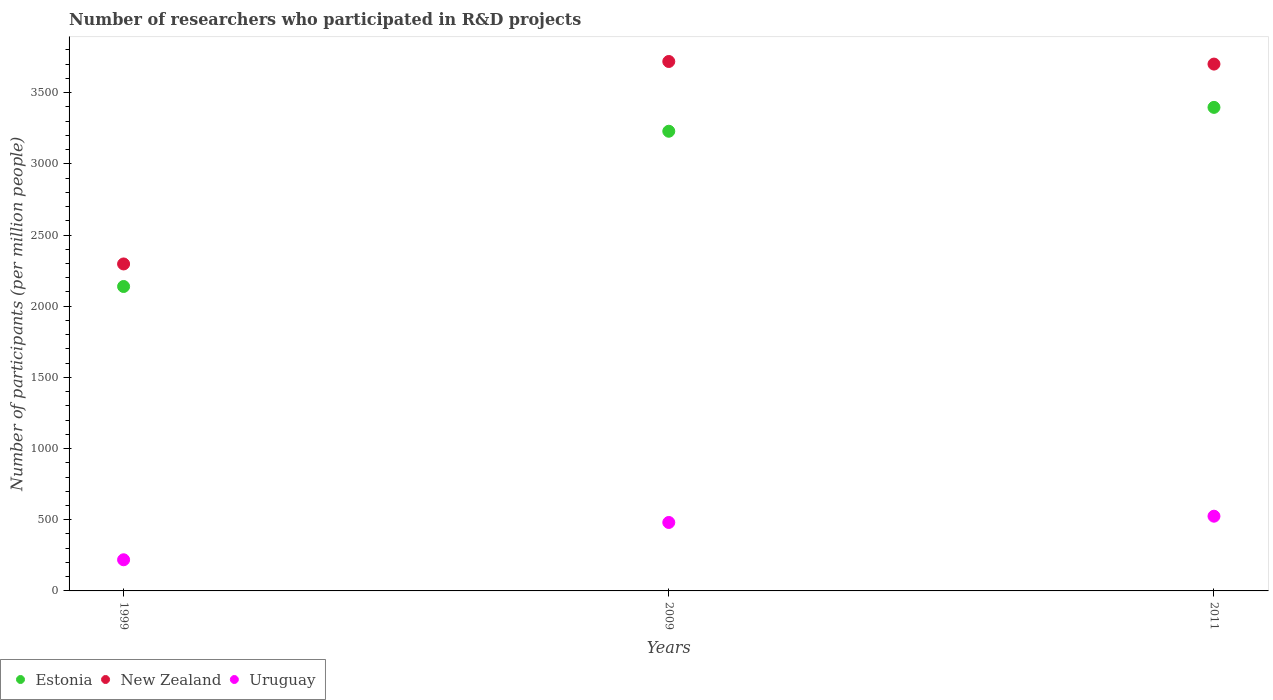Is the number of dotlines equal to the number of legend labels?
Offer a very short reply. Yes. What is the number of researchers who participated in R&D projects in New Zealand in 2011?
Your answer should be very brief. 3700.77. Across all years, what is the maximum number of researchers who participated in R&D projects in Estonia?
Provide a succinct answer. 3396.66. Across all years, what is the minimum number of researchers who participated in R&D projects in New Zealand?
Your answer should be compact. 2296.8. In which year was the number of researchers who participated in R&D projects in Uruguay minimum?
Make the answer very short. 1999. What is the total number of researchers who participated in R&D projects in New Zealand in the graph?
Make the answer very short. 9716.57. What is the difference between the number of researchers who participated in R&D projects in Estonia in 2009 and that in 2011?
Provide a short and direct response. -167.65. What is the difference between the number of researchers who participated in R&D projects in New Zealand in 2011 and the number of researchers who participated in R&D projects in Estonia in 2009?
Your answer should be very brief. 471.76. What is the average number of researchers who participated in R&D projects in New Zealand per year?
Provide a succinct answer. 3238.86. In the year 1999, what is the difference between the number of researchers who participated in R&D projects in Uruguay and number of researchers who participated in R&D projects in New Zealand?
Offer a very short reply. -2077.98. In how many years, is the number of researchers who participated in R&D projects in Uruguay greater than 1900?
Your response must be concise. 0. What is the ratio of the number of researchers who participated in R&D projects in Uruguay in 2009 to that in 2011?
Keep it short and to the point. 0.92. Is the number of researchers who participated in R&D projects in Estonia in 1999 less than that in 2011?
Offer a very short reply. Yes. Is the difference between the number of researchers who participated in R&D projects in Uruguay in 2009 and 2011 greater than the difference between the number of researchers who participated in R&D projects in New Zealand in 2009 and 2011?
Provide a short and direct response. No. What is the difference between the highest and the second highest number of researchers who participated in R&D projects in Estonia?
Provide a succinct answer. 167.65. What is the difference between the highest and the lowest number of researchers who participated in R&D projects in Estonia?
Make the answer very short. 1258.21. In how many years, is the number of researchers who participated in R&D projects in Uruguay greater than the average number of researchers who participated in R&D projects in Uruguay taken over all years?
Offer a very short reply. 2. Is the sum of the number of researchers who participated in R&D projects in New Zealand in 2009 and 2011 greater than the maximum number of researchers who participated in R&D projects in Uruguay across all years?
Give a very brief answer. Yes. Does the number of researchers who participated in R&D projects in Uruguay monotonically increase over the years?
Keep it short and to the point. Yes. Is the number of researchers who participated in R&D projects in Estonia strictly less than the number of researchers who participated in R&D projects in Uruguay over the years?
Give a very brief answer. No. How many dotlines are there?
Your answer should be compact. 3. What is the difference between two consecutive major ticks on the Y-axis?
Provide a succinct answer. 500. Are the values on the major ticks of Y-axis written in scientific E-notation?
Your response must be concise. No. What is the title of the graph?
Your answer should be very brief. Number of researchers who participated in R&D projects. What is the label or title of the Y-axis?
Give a very brief answer. Number of participants (per million people). What is the Number of participants (per million people) in Estonia in 1999?
Give a very brief answer. 2138.45. What is the Number of participants (per million people) of New Zealand in 1999?
Your response must be concise. 2296.8. What is the Number of participants (per million people) in Uruguay in 1999?
Give a very brief answer. 218.82. What is the Number of participants (per million people) in Estonia in 2009?
Make the answer very short. 3229.01. What is the Number of participants (per million people) of New Zealand in 2009?
Provide a succinct answer. 3719. What is the Number of participants (per million people) in Uruguay in 2009?
Provide a short and direct response. 480.85. What is the Number of participants (per million people) of Estonia in 2011?
Provide a succinct answer. 3396.66. What is the Number of participants (per million people) of New Zealand in 2011?
Give a very brief answer. 3700.77. What is the Number of participants (per million people) in Uruguay in 2011?
Give a very brief answer. 524.87. Across all years, what is the maximum Number of participants (per million people) in Estonia?
Make the answer very short. 3396.66. Across all years, what is the maximum Number of participants (per million people) in New Zealand?
Provide a short and direct response. 3719. Across all years, what is the maximum Number of participants (per million people) in Uruguay?
Offer a very short reply. 524.87. Across all years, what is the minimum Number of participants (per million people) in Estonia?
Your answer should be compact. 2138.45. Across all years, what is the minimum Number of participants (per million people) of New Zealand?
Your answer should be very brief. 2296.8. Across all years, what is the minimum Number of participants (per million people) of Uruguay?
Provide a short and direct response. 218.82. What is the total Number of participants (per million people) of Estonia in the graph?
Give a very brief answer. 8764.12. What is the total Number of participants (per million people) of New Zealand in the graph?
Your response must be concise. 9716.57. What is the total Number of participants (per million people) in Uruguay in the graph?
Provide a short and direct response. 1224.54. What is the difference between the Number of participants (per million people) in Estonia in 1999 and that in 2009?
Ensure brevity in your answer.  -1090.56. What is the difference between the Number of participants (per million people) of New Zealand in 1999 and that in 2009?
Ensure brevity in your answer.  -1422.2. What is the difference between the Number of participants (per million people) in Uruguay in 1999 and that in 2009?
Your response must be concise. -262.04. What is the difference between the Number of participants (per million people) in Estonia in 1999 and that in 2011?
Provide a succinct answer. -1258.21. What is the difference between the Number of participants (per million people) of New Zealand in 1999 and that in 2011?
Offer a very short reply. -1403.98. What is the difference between the Number of participants (per million people) of Uruguay in 1999 and that in 2011?
Make the answer very short. -306.05. What is the difference between the Number of participants (per million people) of Estonia in 2009 and that in 2011?
Make the answer very short. -167.65. What is the difference between the Number of participants (per million people) in New Zealand in 2009 and that in 2011?
Provide a short and direct response. 18.22. What is the difference between the Number of participants (per million people) of Uruguay in 2009 and that in 2011?
Provide a succinct answer. -44.01. What is the difference between the Number of participants (per million people) in Estonia in 1999 and the Number of participants (per million people) in New Zealand in 2009?
Your response must be concise. -1580.55. What is the difference between the Number of participants (per million people) in Estonia in 1999 and the Number of participants (per million people) in Uruguay in 2009?
Your answer should be compact. 1657.59. What is the difference between the Number of participants (per million people) in New Zealand in 1999 and the Number of participants (per million people) in Uruguay in 2009?
Provide a succinct answer. 1815.94. What is the difference between the Number of participants (per million people) in Estonia in 1999 and the Number of participants (per million people) in New Zealand in 2011?
Provide a succinct answer. -1562.33. What is the difference between the Number of participants (per million people) of Estonia in 1999 and the Number of participants (per million people) of Uruguay in 2011?
Give a very brief answer. 1613.58. What is the difference between the Number of participants (per million people) of New Zealand in 1999 and the Number of participants (per million people) of Uruguay in 2011?
Your answer should be compact. 1771.93. What is the difference between the Number of participants (per million people) of Estonia in 2009 and the Number of participants (per million people) of New Zealand in 2011?
Offer a terse response. -471.76. What is the difference between the Number of participants (per million people) in Estonia in 2009 and the Number of participants (per million people) in Uruguay in 2011?
Your answer should be compact. 2704.14. What is the difference between the Number of participants (per million people) of New Zealand in 2009 and the Number of participants (per million people) of Uruguay in 2011?
Give a very brief answer. 3194.13. What is the average Number of participants (per million people) of Estonia per year?
Provide a short and direct response. 2921.37. What is the average Number of participants (per million people) in New Zealand per year?
Provide a short and direct response. 3238.86. What is the average Number of participants (per million people) in Uruguay per year?
Make the answer very short. 408.18. In the year 1999, what is the difference between the Number of participants (per million people) in Estonia and Number of participants (per million people) in New Zealand?
Ensure brevity in your answer.  -158.35. In the year 1999, what is the difference between the Number of participants (per million people) of Estonia and Number of participants (per million people) of Uruguay?
Make the answer very short. 1919.63. In the year 1999, what is the difference between the Number of participants (per million people) of New Zealand and Number of participants (per million people) of Uruguay?
Give a very brief answer. 2077.98. In the year 2009, what is the difference between the Number of participants (per million people) in Estonia and Number of participants (per million people) in New Zealand?
Offer a terse response. -489.99. In the year 2009, what is the difference between the Number of participants (per million people) in Estonia and Number of participants (per million people) in Uruguay?
Offer a very short reply. 2748.16. In the year 2009, what is the difference between the Number of participants (per million people) in New Zealand and Number of participants (per million people) in Uruguay?
Give a very brief answer. 3238.14. In the year 2011, what is the difference between the Number of participants (per million people) of Estonia and Number of participants (per million people) of New Zealand?
Provide a short and direct response. -304.11. In the year 2011, what is the difference between the Number of participants (per million people) of Estonia and Number of participants (per million people) of Uruguay?
Provide a short and direct response. 2871.79. In the year 2011, what is the difference between the Number of participants (per million people) in New Zealand and Number of participants (per million people) in Uruguay?
Your response must be concise. 3175.91. What is the ratio of the Number of participants (per million people) of Estonia in 1999 to that in 2009?
Your answer should be very brief. 0.66. What is the ratio of the Number of participants (per million people) of New Zealand in 1999 to that in 2009?
Offer a terse response. 0.62. What is the ratio of the Number of participants (per million people) of Uruguay in 1999 to that in 2009?
Ensure brevity in your answer.  0.46. What is the ratio of the Number of participants (per million people) of Estonia in 1999 to that in 2011?
Ensure brevity in your answer.  0.63. What is the ratio of the Number of participants (per million people) of New Zealand in 1999 to that in 2011?
Keep it short and to the point. 0.62. What is the ratio of the Number of participants (per million people) of Uruguay in 1999 to that in 2011?
Offer a terse response. 0.42. What is the ratio of the Number of participants (per million people) of Estonia in 2009 to that in 2011?
Provide a short and direct response. 0.95. What is the ratio of the Number of participants (per million people) of New Zealand in 2009 to that in 2011?
Offer a very short reply. 1. What is the ratio of the Number of participants (per million people) in Uruguay in 2009 to that in 2011?
Keep it short and to the point. 0.92. What is the difference between the highest and the second highest Number of participants (per million people) of Estonia?
Provide a short and direct response. 167.65. What is the difference between the highest and the second highest Number of participants (per million people) of New Zealand?
Keep it short and to the point. 18.22. What is the difference between the highest and the second highest Number of participants (per million people) in Uruguay?
Your answer should be compact. 44.01. What is the difference between the highest and the lowest Number of participants (per million people) of Estonia?
Ensure brevity in your answer.  1258.21. What is the difference between the highest and the lowest Number of participants (per million people) of New Zealand?
Make the answer very short. 1422.2. What is the difference between the highest and the lowest Number of participants (per million people) of Uruguay?
Offer a terse response. 306.05. 